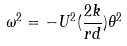Convert formula to latex. <formula><loc_0><loc_0><loc_500><loc_500>\omega ^ { 2 } = - U ^ { 2 } ( \frac { 2 k } { r d } ) \theta ^ { 2 }</formula> 